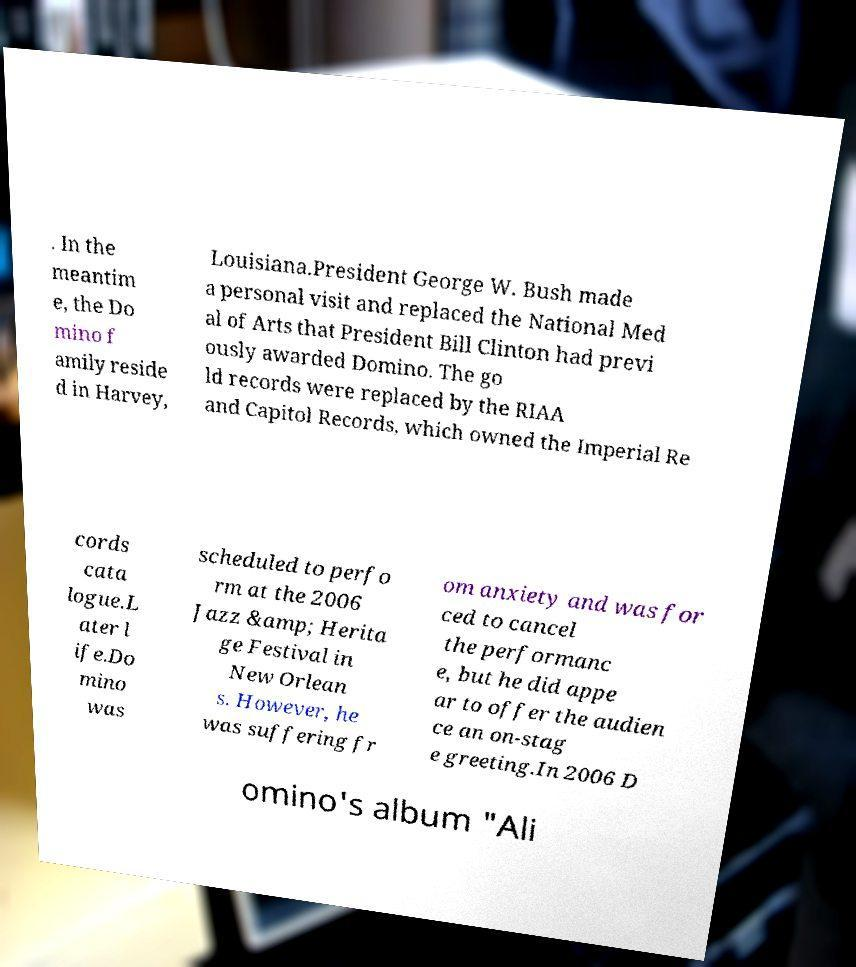What messages or text are displayed in this image? I need them in a readable, typed format. . In the meantim e, the Do mino f amily reside d in Harvey, Louisiana.President George W. Bush made a personal visit and replaced the National Med al of Arts that President Bill Clinton had previ ously awarded Domino. The go ld records were replaced by the RIAA and Capitol Records, which owned the Imperial Re cords cata logue.L ater l ife.Do mino was scheduled to perfo rm at the 2006 Jazz &amp; Herita ge Festival in New Orlean s. However, he was suffering fr om anxiety and was for ced to cancel the performanc e, but he did appe ar to offer the audien ce an on-stag e greeting.In 2006 D omino's album "Ali 